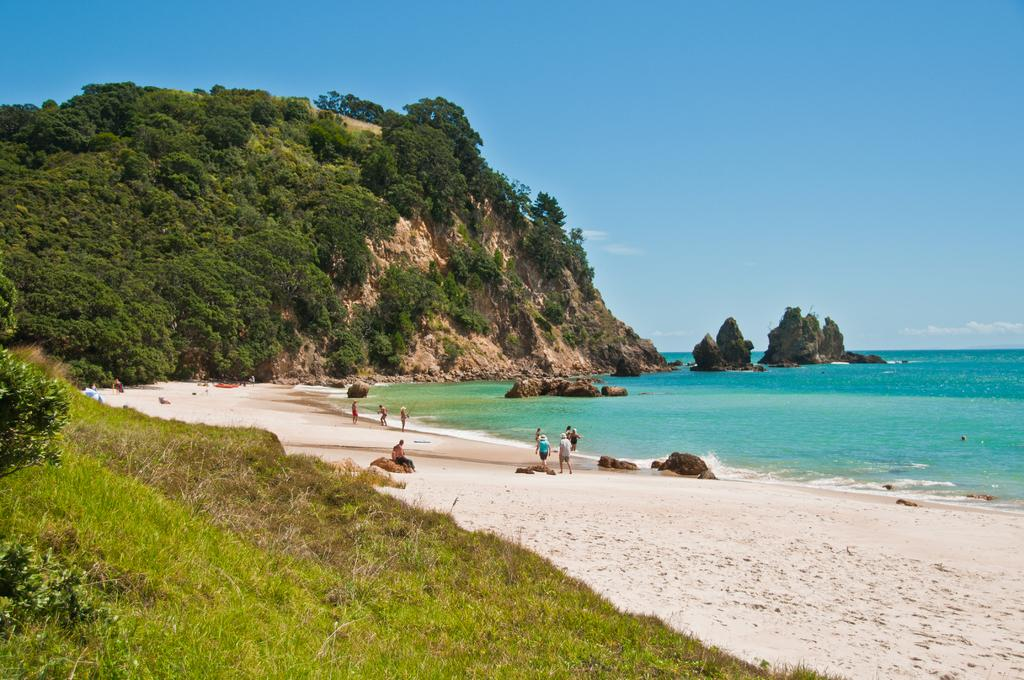What can be seen in the background of the image? The sky is visible in the background of the image. What type of vegetation is present in the image? There is a thicket, plants, and grass visible in the image. What geographical feature is in the image? There is a mountain in the image. Where is the seashore located in the image? The seashore is visible in the image. What type of terrain is present in the image? Rocks are present in the image. Are there any people in the image? Yes, there are people in the image. What month is it in the image? The month cannot be determined from the image, as it does not contain any information about the time of year. What type of business is being conducted in the image? There is no indication of any business activity in the image. 